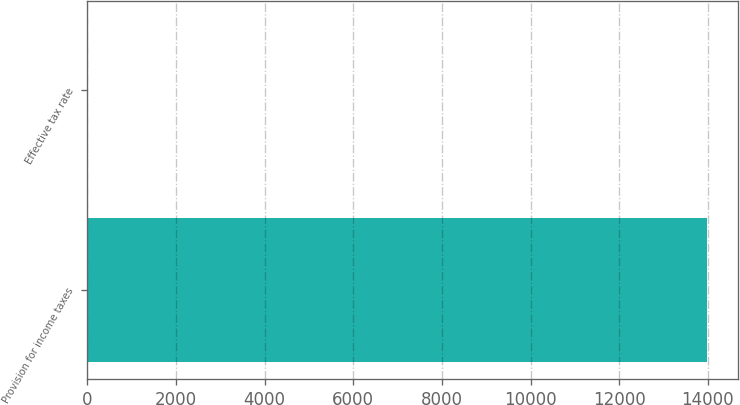Convert chart. <chart><loc_0><loc_0><loc_500><loc_500><bar_chart><fcel>Provision for income taxes<fcel>Effective tax rate<nl><fcel>13973<fcel>26.1<nl></chart> 